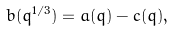<formula> <loc_0><loc_0><loc_500><loc_500>b ( q ^ { 1 / 3 } ) = a ( q ) - c ( q ) ,</formula> 